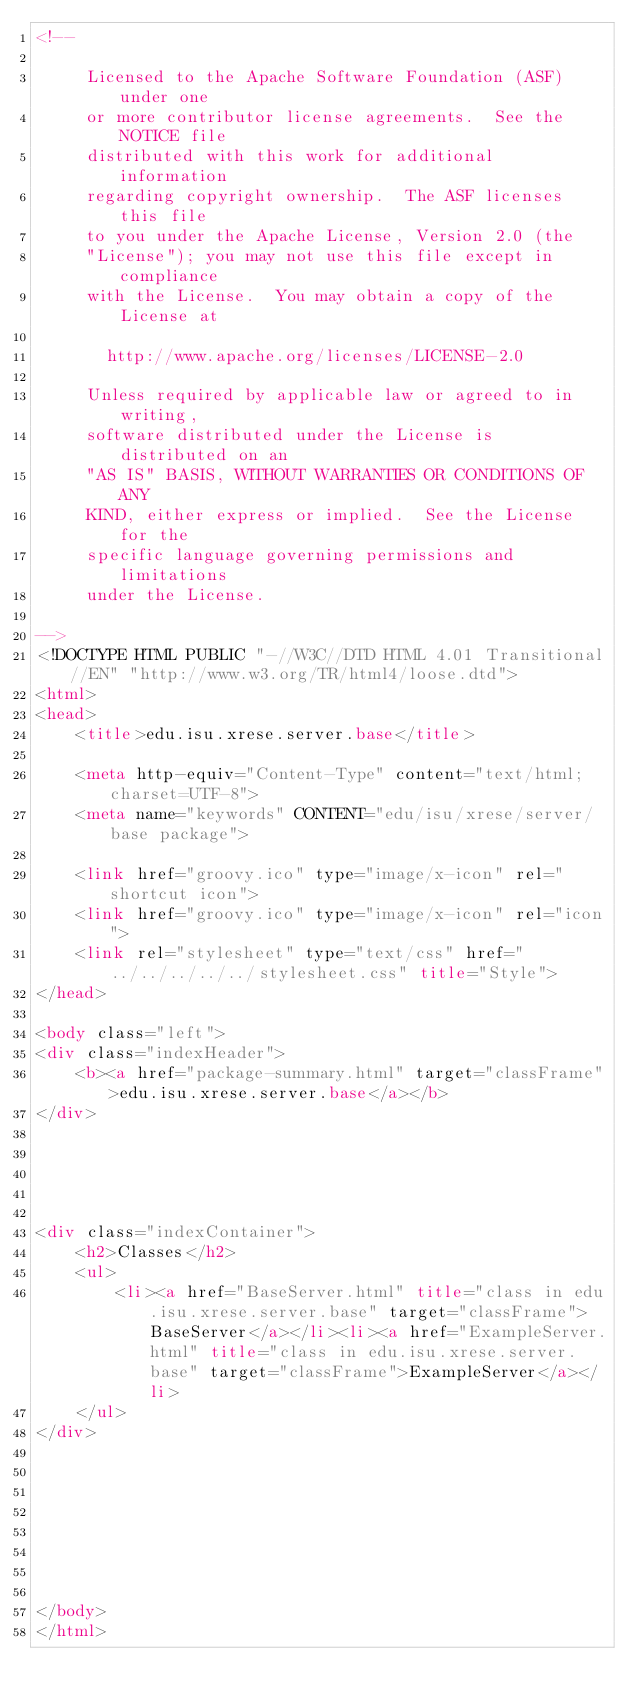Convert code to text. <code><loc_0><loc_0><loc_500><loc_500><_HTML_><!--

     Licensed to the Apache Software Foundation (ASF) under one
     or more contributor license agreements.  See the NOTICE file
     distributed with this work for additional information
     regarding copyright ownership.  The ASF licenses this file
     to you under the Apache License, Version 2.0 (the
     "License"); you may not use this file except in compliance
     with the License.  You may obtain a copy of the License at

       http://www.apache.org/licenses/LICENSE-2.0

     Unless required by applicable law or agreed to in writing,
     software distributed under the License is distributed on an
     "AS IS" BASIS, WITHOUT WARRANTIES OR CONDITIONS OF ANY
     KIND, either express or implied.  See the License for the
     specific language governing permissions and limitations
     under the License.

-->
<!DOCTYPE HTML PUBLIC "-//W3C//DTD HTML 4.01 Transitional//EN" "http://www.w3.org/TR/html4/loose.dtd">
<html>
<head>
    <title>edu.isu.xrese.server.base</title>
    
    <meta http-equiv="Content-Type" content="text/html; charset=UTF-8">
    <meta name="keywords" CONTENT="edu/isu/xrese/server/base package">

    <link href="groovy.ico" type="image/x-icon" rel="shortcut icon">
    <link href="groovy.ico" type="image/x-icon" rel="icon">
    <link rel="stylesheet" type="text/css" href="../../../../../stylesheet.css" title="Style">
</head>

<body class="left">
<div class="indexHeader">
    <b><a href="package-summary.html" target="classFrame">edu.isu.xrese.server.base</a></b>
</div>





<div class="indexContainer">
    <h2>Classes</h2>
    <ul>
        <li><a href="BaseServer.html" title="class in edu.isu.xrese.server.base" target="classFrame">BaseServer</a></li><li><a href="ExampleServer.html" title="class in edu.isu.xrese.server.base" target="classFrame">ExampleServer</a></li>
    </ul>
</div>








</body>
</html>
</code> 